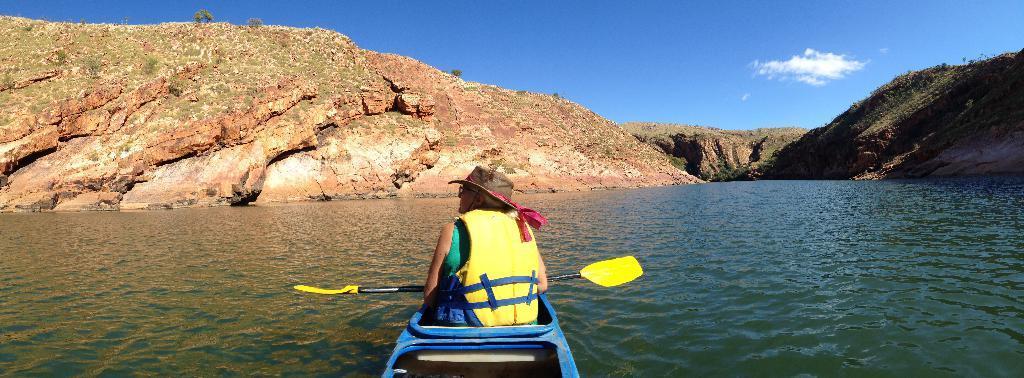How would you summarize this image in a sentence or two? In this image we can see a person sitting on the boat, there are trees, mountains, also we can see the sky, and the river. 